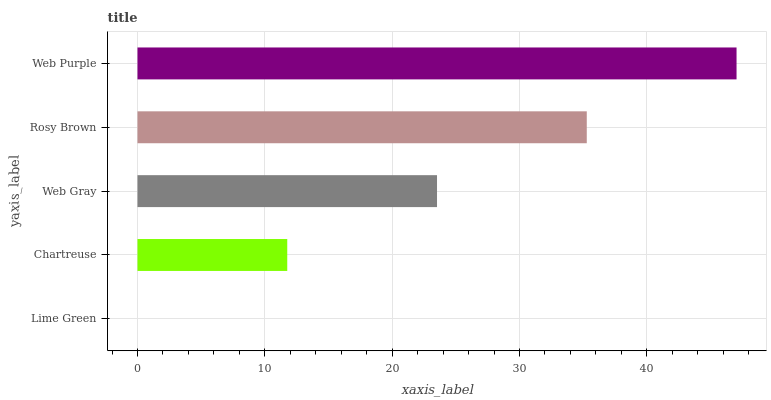Is Lime Green the minimum?
Answer yes or no. Yes. Is Web Purple the maximum?
Answer yes or no. Yes. Is Chartreuse the minimum?
Answer yes or no. No. Is Chartreuse the maximum?
Answer yes or no. No. Is Chartreuse greater than Lime Green?
Answer yes or no. Yes. Is Lime Green less than Chartreuse?
Answer yes or no. Yes. Is Lime Green greater than Chartreuse?
Answer yes or no. No. Is Chartreuse less than Lime Green?
Answer yes or no. No. Is Web Gray the high median?
Answer yes or no. Yes. Is Web Gray the low median?
Answer yes or no. Yes. Is Web Purple the high median?
Answer yes or no. No. Is Rosy Brown the low median?
Answer yes or no. No. 